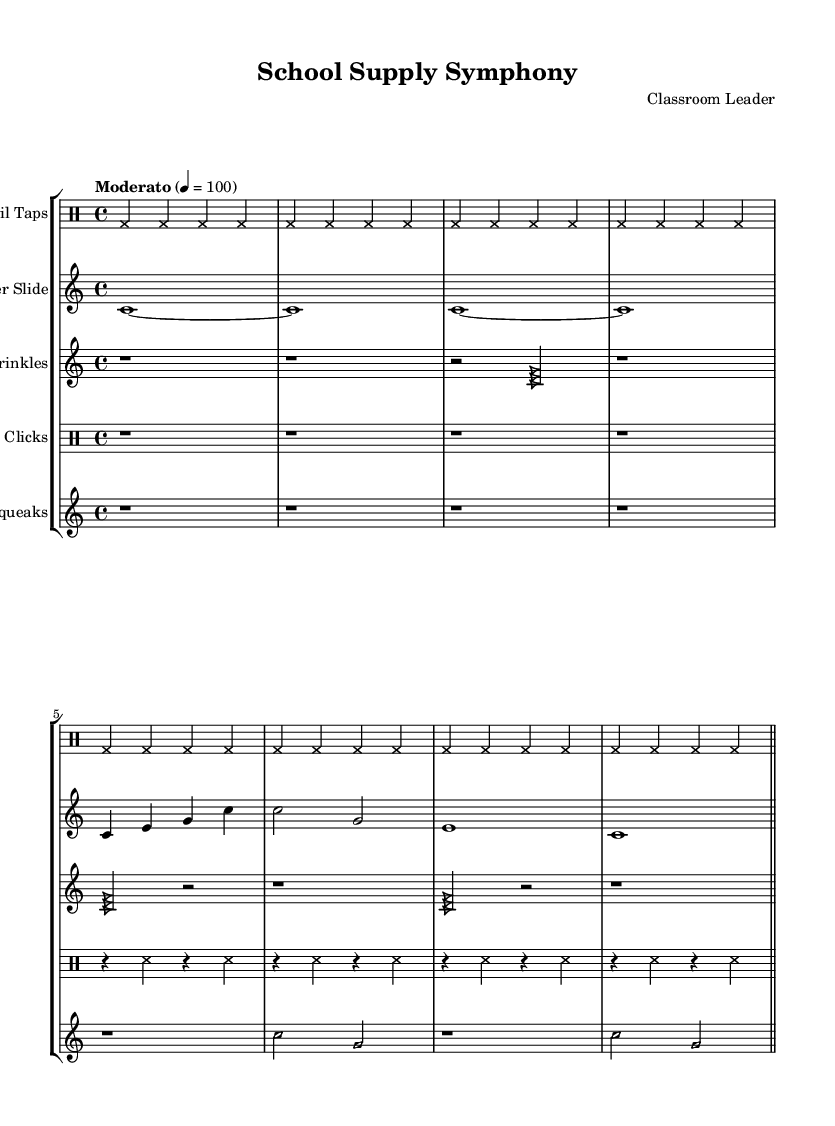What is the time signature of this music? The time signature is indicated as 4/4 at the beginning of the pencil taps section, which describes how many beats are in a measure and which note value is considered one beat.
Answer: 4/4 What is the tempo marking for "Pencil Taps"? The tempo marking is stated as "Moderato," which suggests a moderate speed for the performance, indicated to be at 100 beats per minute.
Answer: Moderato How many different sections are represented in the sheet music? The sheet music has five distinct sections, each using different school supplies as instruments: Pencil Taps, Ruler Slide, Paper Crinkles, Stapler Clicks, and Eraser Squeaks.
Answer: Five Which instrument uses cross note heads? The instrument using cross note heads is "Pencil Taps" and "Stapler Clicks," as indicated in their respective sections where the note head style is set to 'cross'.
Answer: Pencil Taps and Stapler Clicks What type of musical notation is used for "Paper Crinkles"? "Paper Crinkles" employs triangle note heads for its musical notation, as specified in the section where note head style is set to 'triangle'.
Answer: Triangle What is the first pitch used in the "Ruler Slide" section? The first pitch in the "Ruler Slide" section is C, as the melody starts with the note C played in a sustained manner.
Answer: C How many rests are there in the "Eraser Squeaks" section? There are four rests in the "Eraser Squeaks" section, which are evenly distributed at the start of each measure as shown in the rhythmic pattern.
Answer: Four 